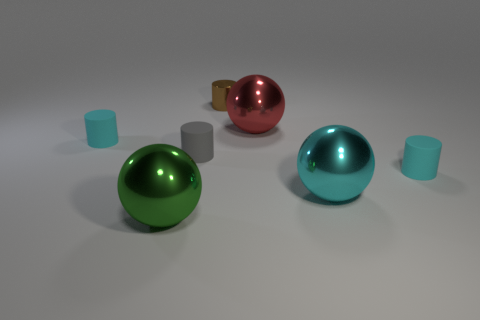There is a cylinder on the left side of the green metal thing; is its color the same as the small metallic cylinder?
Offer a very short reply. No. How many cyan rubber objects are on the left side of the brown metallic object and right of the small brown metal object?
Provide a succinct answer. 0. How many other objects are there of the same material as the tiny gray cylinder?
Your response must be concise. 2. Is the cyan cylinder that is behind the small gray matte object made of the same material as the big cyan ball?
Keep it short and to the point. No. What size is the metal object left of the tiny thing behind the tiny rubber object left of the green thing?
Make the answer very short. Large. What number of other objects are the same color as the small metallic cylinder?
Your answer should be very brief. 0. There is a green metal thing that is the same size as the red metal thing; what shape is it?
Keep it short and to the point. Sphere. There is a shiny ball that is left of the brown shiny object; how big is it?
Provide a succinct answer. Large. There is a matte object on the left side of the big green shiny sphere; does it have the same color as the small rubber cylinder right of the cyan sphere?
Provide a succinct answer. Yes. What material is the small cyan cylinder behind the small cyan rubber cylinder in front of the matte cylinder on the left side of the green object?
Give a very brief answer. Rubber. 